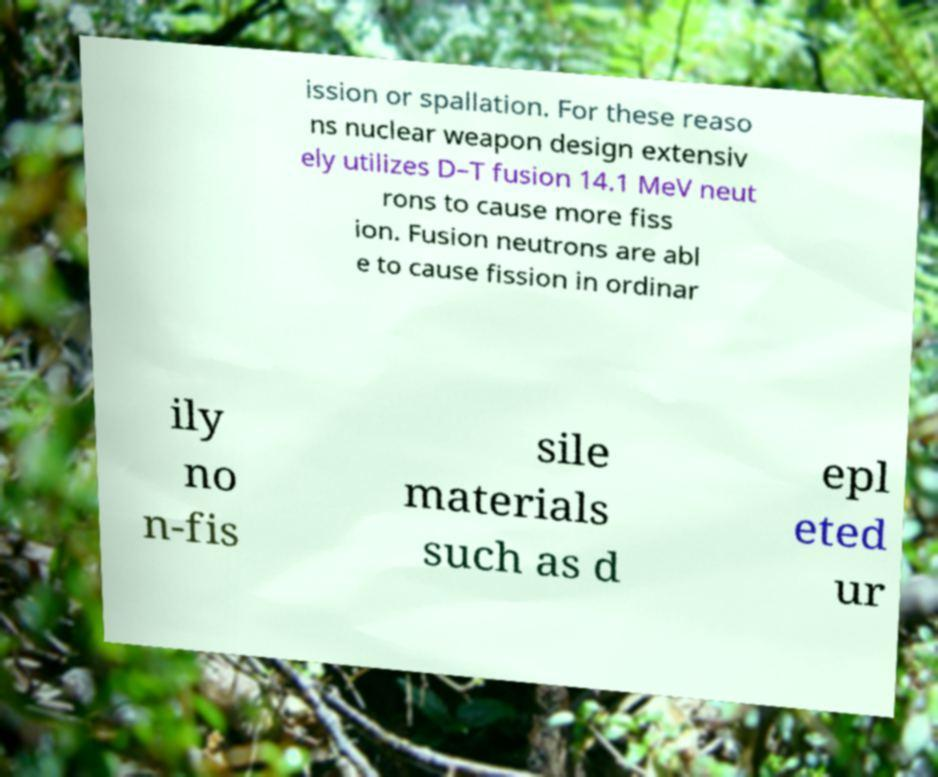Please read and relay the text visible in this image. What does it say? ission or spallation. For these reaso ns nuclear weapon design extensiv ely utilizes D–T fusion 14.1 MeV neut rons to cause more fiss ion. Fusion neutrons are abl e to cause fission in ordinar ily no n-fis sile materials such as d epl eted ur 